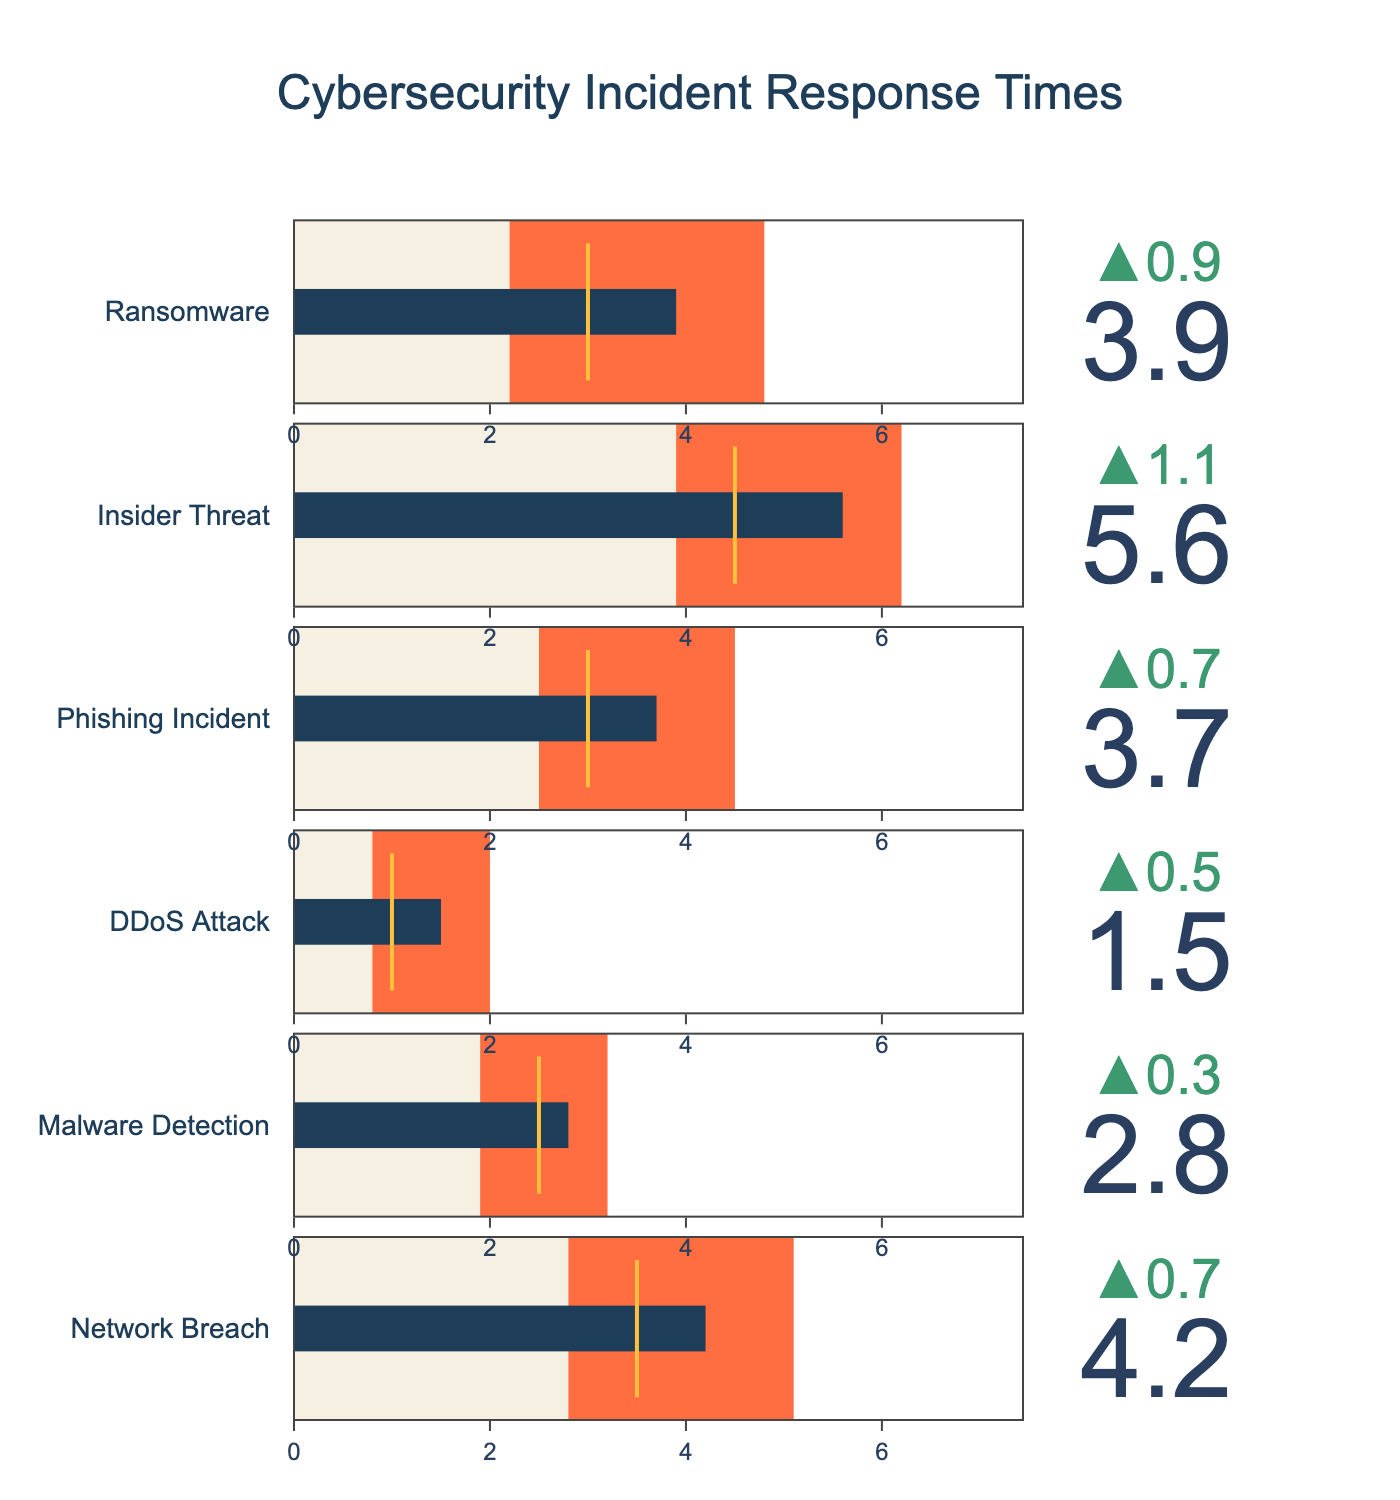What's the title of the figure? The title is generally placed at the top of the figure. It provides a summary of the content being displayed. Here, the title is visible as it's a part of the plot configuration.
Answer: Cybersecurity Incident Response Times How many categories of cybersecurity incidents are shown in the figure? Count the number of distinct categories listed along the vertical axis of the bullet chart. Each bullet represents a different category.
Answer: 6 What's the actual response time for the "Phishing Incident"? Locate the bullet chart for "Phishing Incident" and check the value marked as "Actual" which is the core value displayed on the bullet.
Answer: 3.7 Which category has the highest target response time? Compare the target response times for each category to identify which one is the highest.
Answer: Insider Threat What's the difference between the industry average and the best in class for a "Network Breach"? Subtract the best in class response time from the industry average response time for the "Network Breach" category.
Answer: 5.1 - 2.8 = 2.3 How does the actual response time for "Malware Detection" compare to the target response time for the same category? Look at both the actual and target response times for "Malware Detection". Determine if the actual time is higher or lower than the target time.
Answer: Higher Which incident type has the most considerable discrepancy between actual and best in class response time? For each category, subtract the best in class response time from the actual response time. The category with the highest result will have the most considerable discrepancy.
Answer: Insider Threat Are there any categories where the actual response time meets or is better than the best in class response time? Compare the actual response times with the best in class response times for each category to see if any actual time is equal to or less than the best in class.
Answer: No What's the average target response time across all categories? Sum up all target response times and divide by the number of categories.
Answer: (3.5 + 2.5 + 1.0 + 3.0 + 4.5 + 3.0) / 6 = 2.92 Which category requires the most improvement to reach its target response time? Find the category with the highest difference between the actual response time and the target response time by subtracting the target time from the actual time.
Answer: Insider Threat 